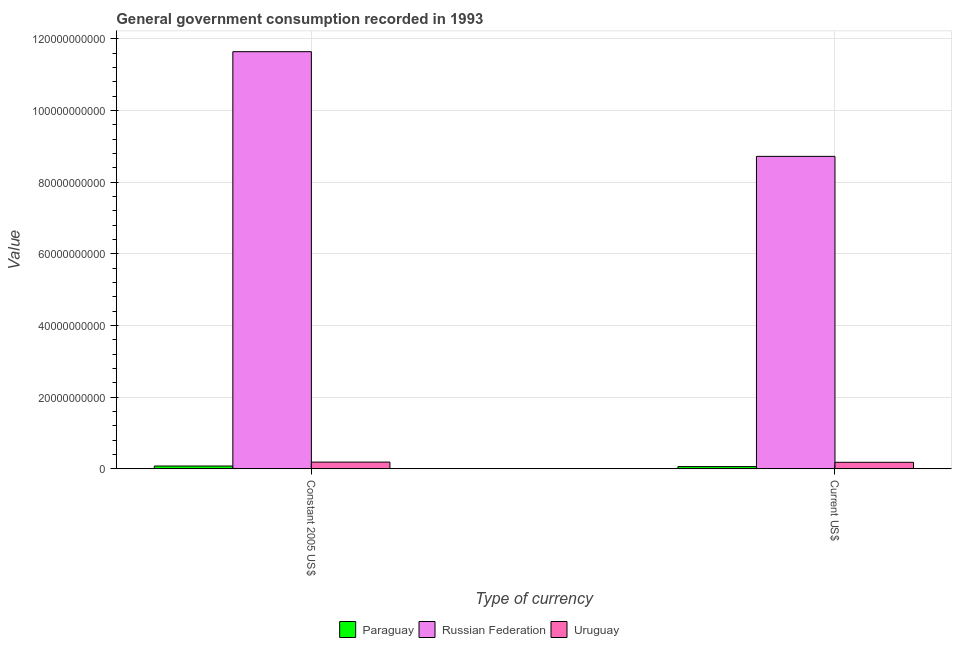How many different coloured bars are there?
Keep it short and to the point. 3. Are the number of bars per tick equal to the number of legend labels?
Provide a succinct answer. Yes. Are the number of bars on each tick of the X-axis equal?
Ensure brevity in your answer.  Yes. How many bars are there on the 2nd tick from the right?
Your answer should be very brief. 3. What is the label of the 1st group of bars from the left?
Make the answer very short. Constant 2005 US$. What is the value consumed in current us$ in Russian Federation?
Give a very brief answer. 8.72e+1. Across all countries, what is the maximum value consumed in current us$?
Offer a terse response. 8.72e+1. Across all countries, what is the minimum value consumed in current us$?
Your response must be concise. 6.29e+08. In which country was the value consumed in constant 2005 us$ maximum?
Offer a very short reply. Russian Federation. In which country was the value consumed in current us$ minimum?
Provide a short and direct response. Paraguay. What is the total value consumed in current us$ in the graph?
Offer a very short reply. 8.96e+1. What is the difference between the value consumed in constant 2005 us$ in Russian Federation and that in Paraguay?
Give a very brief answer. 1.16e+11. What is the difference between the value consumed in current us$ in Uruguay and the value consumed in constant 2005 us$ in Paraguay?
Give a very brief answer. 1.04e+09. What is the average value consumed in constant 2005 us$ per country?
Offer a terse response. 3.97e+1. What is the difference between the value consumed in constant 2005 us$ and value consumed in current us$ in Paraguay?
Offer a very short reply. 1.57e+08. In how many countries, is the value consumed in current us$ greater than 44000000000 ?
Offer a terse response. 1. What is the ratio of the value consumed in current us$ in Uruguay to that in Paraguay?
Give a very brief answer. 2.91. In how many countries, is the value consumed in current us$ greater than the average value consumed in current us$ taken over all countries?
Keep it short and to the point. 1. What does the 3rd bar from the left in Constant 2005 US$ represents?
Your answer should be compact. Uruguay. What does the 1st bar from the right in Current US$ represents?
Your response must be concise. Uruguay. Are all the bars in the graph horizontal?
Your answer should be compact. No. How many countries are there in the graph?
Keep it short and to the point. 3. Are the values on the major ticks of Y-axis written in scientific E-notation?
Your response must be concise. No. Does the graph contain any zero values?
Provide a succinct answer. No. What is the title of the graph?
Your answer should be compact. General government consumption recorded in 1993. Does "Gambia, The" appear as one of the legend labels in the graph?
Offer a very short reply. No. What is the label or title of the X-axis?
Ensure brevity in your answer.  Type of currency. What is the label or title of the Y-axis?
Keep it short and to the point. Value. What is the Value in Paraguay in Constant 2005 US$?
Your response must be concise. 7.86e+08. What is the Value of Russian Federation in Constant 2005 US$?
Provide a succinct answer. 1.16e+11. What is the Value in Uruguay in Constant 2005 US$?
Offer a terse response. 1.88e+09. What is the Value in Paraguay in Current US$?
Ensure brevity in your answer.  6.29e+08. What is the Value of Russian Federation in Current US$?
Offer a very short reply. 8.72e+1. What is the Value of Uruguay in Current US$?
Keep it short and to the point. 1.83e+09. Across all Type of currency, what is the maximum Value in Paraguay?
Offer a very short reply. 7.86e+08. Across all Type of currency, what is the maximum Value in Russian Federation?
Your answer should be very brief. 1.16e+11. Across all Type of currency, what is the maximum Value in Uruguay?
Your answer should be compact. 1.88e+09. Across all Type of currency, what is the minimum Value in Paraguay?
Provide a short and direct response. 6.29e+08. Across all Type of currency, what is the minimum Value in Russian Federation?
Provide a short and direct response. 8.72e+1. Across all Type of currency, what is the minimum Value in Uruguay?
Offer a terse response. 1.83e+09. What is the total Value of Paraguay in the graph?
Your answer should be compact. 1.41e+09. What is the total Value in Russian Federation in the graph?
Provide a succinct answer. 2.04e+11. What is the total Value in Uruguay in the graph?
Provide a succinct answer. 3.71e+09. What is the difference between the Value of Paraguay in Constant 2005 US$ and that in Current US$?
Your response must be concise. 1.57e+08. What is the difference between the Value in Russian Federation in Constant 2005 US$ and that in Current US$?
Provide a succinct answer. 2.92e+1. What is the difference between the Value of Uruguay in Constant 2005 US$ and that in Current US$?
Make the answer very short. 5.69e+07. What is the difference between the Value of Paraguay in Constant 2005 US$ and the Value of Russian Federation in Current US$?
Provide a short and direct response. -8.64e+1. What is the difference between the Value in Paraguay in Constant 2005 US$ and the Value in Uruguay in Current US$?
Ensure brevity in your answer.  -1.04e+09. What is the difference between the Value in Russian Federation in Constant 2005 US$ and the Value in Uruguay in Current US$?
Give a very brief answer. 1.15e+11. What is the average Value of Paraguay per Type of currency?
Provide a short and direct response. 7.07e+08. What is the average Value in Russian Federation per Type of currency?
Give a very brief answer. 1.02e+11. What is the average Value in Uruguay per Type of currency?
Your response must be concise. 1.86e+09. What is the difference between the Value of Paraguay and Value of Russian Federation in Constant 2005 US$?
Your answer should be compact. -1.16e+11. What is the difference between the Value in Paraguay and Value in Uruguay in Constant 2005 US$?
Give a very brief answer. -1.10e+09. What is the difference between the Value in Russian Federation and Value in Uruguay in Constant 2005 US$?
Offer a terse response. 1.15e+11. What is the difference between the Value in Paraguay and Value in Russian Federation in Current US$?
Ensure brevity in your answer.  -8.66e+1. What is the difference between the Value of Paraguay and Value of Uruguay in Current US$?
Your answer should be very brief. -1.20e+09. What is the difference between the Value in Russian Federation and Value in Uruguay in Current US$?
Make the answer very short. 8.54e+1. What is the ratio of the Value in Paraguay in Constant 2005 US$ to that in Current US$?
Make the answer very short. 1.25. What is the ratio of the Value in Russian Federation in Constant 2005 US$ to that in Current US$?
Give a very brief answer. 1.33. What is the ratio of the Value in Uruguay in Constant 2005 US$ to that in Current US$?
Make the answer very short. 1.03. What is the difference between the highest and the second highest Value in Paraguay?
Your answer should be very brief. 1.57e+08. What is the difference between the highest and the second highest Value in Russian Federation?
Provide a short and direct response. 2.92e+1. What is the difference between the highest and the second highest Value in Uruguay?
Offer a very short reply. 5.69e+07. What is the difference between the highest and the lowest Value of Paraguay?
Offer a very short reply. 1.57e+08. What is the difference between the highest and the lowest Value in Russian Federation?
Keep it short and to the point. 2.92e+1. What is the difference between the highest and the lowest Value of Uruguay?
Give a very brief answer. 5.69e+07. 